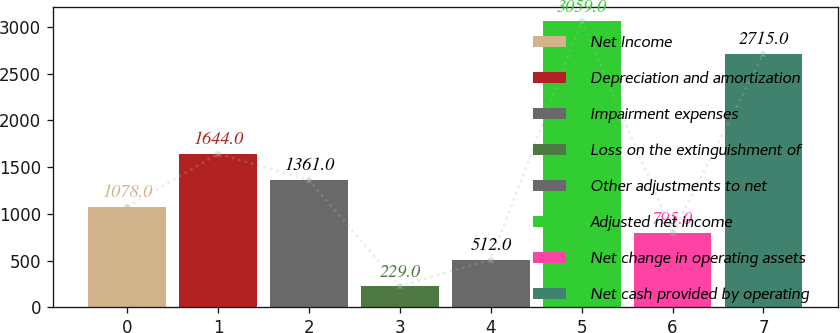<chart> <loc_0><loc_0><loc_500><loc_500><bar_chart><fcel>Net Income<fcel>Depreciation and amortization<fcel>Impairment expenses<fcel>Loss on the extinguishment of<fcel>Other adjustments to net<fcel>Adjusted net income<fcel>Net change in operating assets<fcel>Net cash provided by operating<nl><fcel>1078<fcel>1644<fcel>1361<fcel>229<fcel>512<fcel>3059<fcel>795<fcel>2715<nl></chart> 